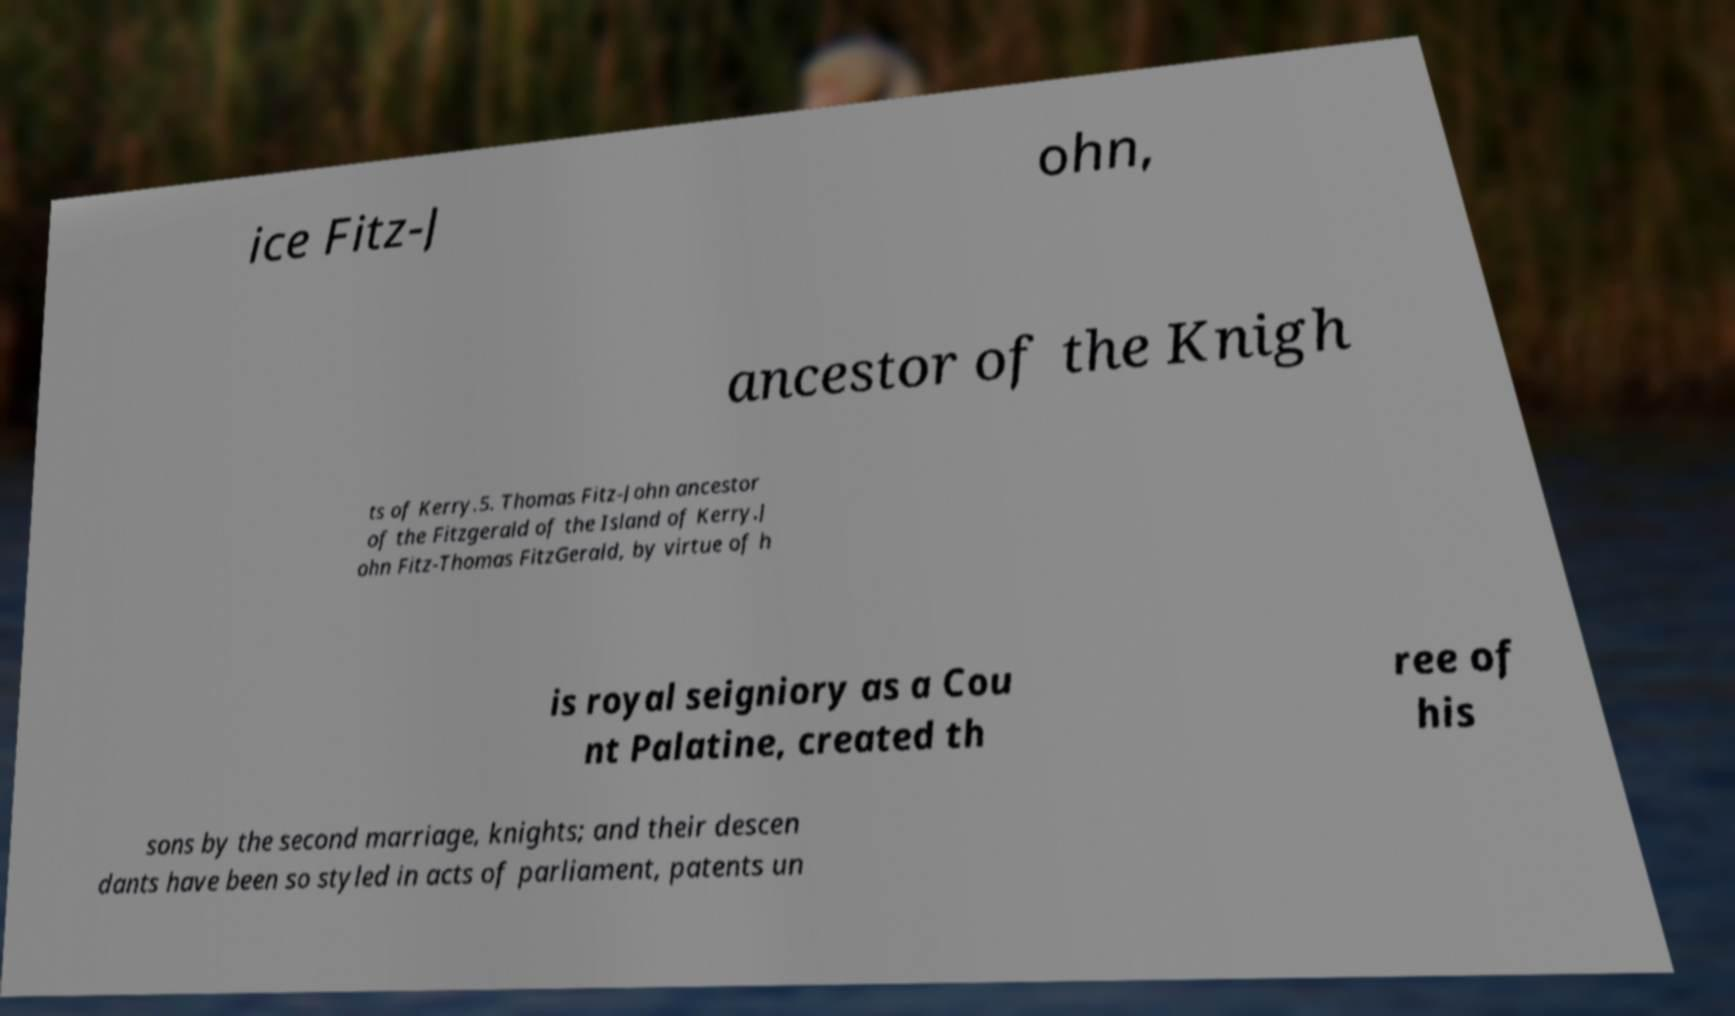For documentation purposes, I need the text within this image transcribed. Could you provide that? ice Fitz-J ohn, ancestor of the Knigh ts of Kerry.5. Thomas Fitz-John ancestor of the Fitzgerald of the Island of Kerry.J ohn Fitz-Thomas FitzGerald, by virtue of h is royal seigniory as a Cou nt Palatine, created th ree of his sons by the second marriage, knights; and their descen dants have been so styled in acts of parliament, patents un 